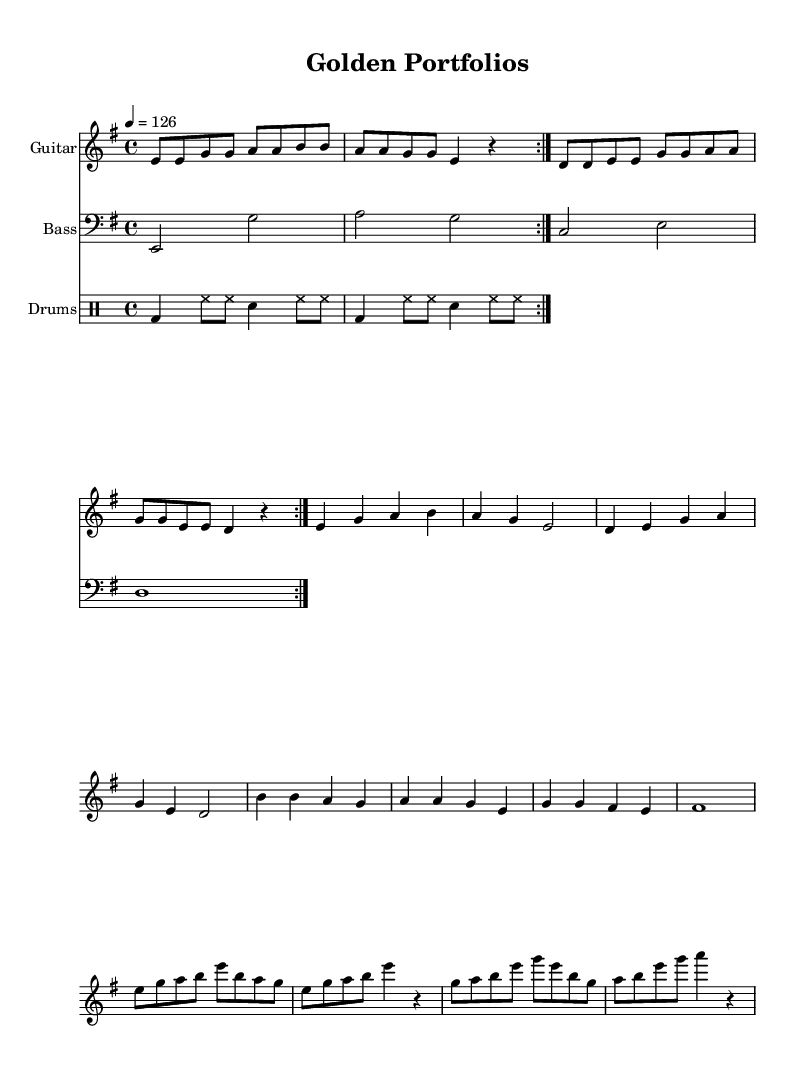What is the key signature of this music? The key signature is E minor, which contains one sharp, F#. It can be identified from the key indicated at the beginning of the score.
Answer: E minor What is the time signature of this music? The time signature is 4/4, meaning there are four beats in each measure and the quarter note gets one beat. This can be found in the opening measures of the score.
Answer: 4/4 What is the tempo marking of the piece? The tempo marking is 126, indicating the beats per minute (BPM) for the music. This is specified at the start with the indication of "4 = 126".
Answer: 126 How many bars are in the guitar riff section? The guitar riff section consists of 8 bars, as seen from the measure layout and counting the measures represented.
Answer: 8 What type of lyrics are presented in this piece? The lyrics presented in the piece are about financial success and wealth, as suggested by phrases like "Stocks and bonds" and "golden portfolios." This can be inferred from the lyrical content provided in the score.
Answer: Financial success Which instrument is the main focus in the solo section? The main focus in the solo section is the guitar, as indicated by the specific notation for the guitar solo part within the score.
Answer: Guitar What is the style of the song based on its musical characteristics? The style of the song is classic heavy metal, characterized by its use of electric guitar riffs, a driving rhythm section, and powerful vocal themes. This style can be determined by the general structure and instrumentation outlined in the score.
Answer: Classic heavy metal 